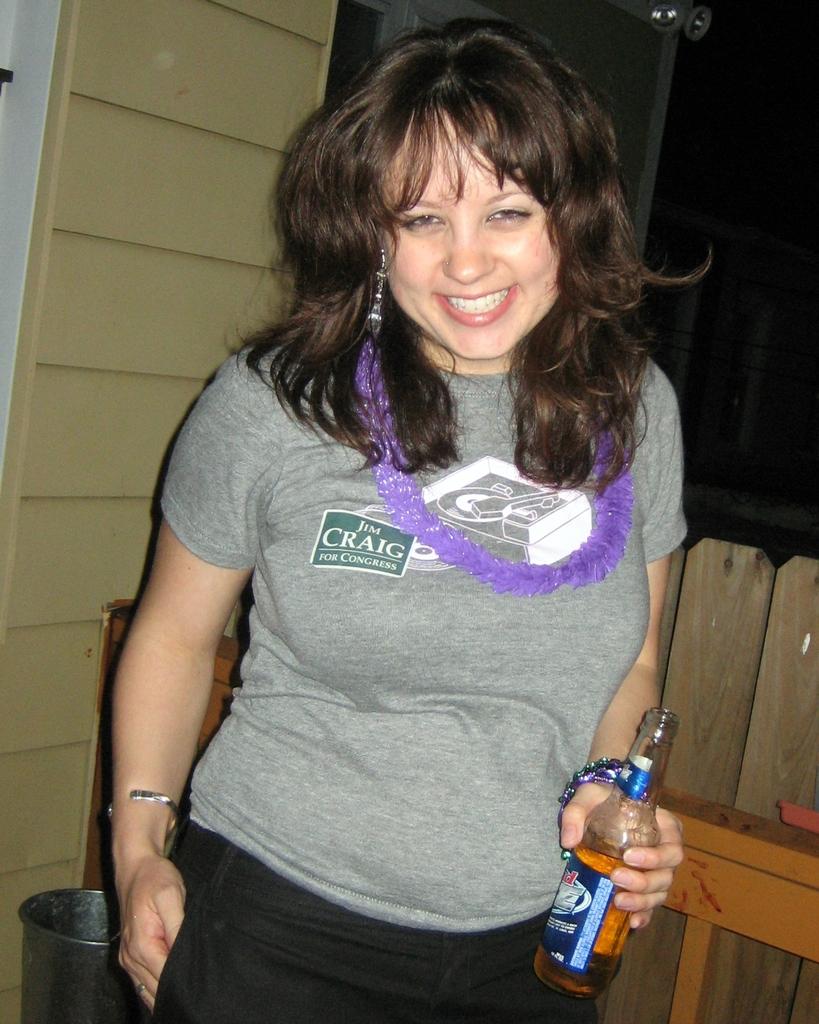What does the sticker on the shirt say?
Your answer should be very brief. Jim craig for congress. 